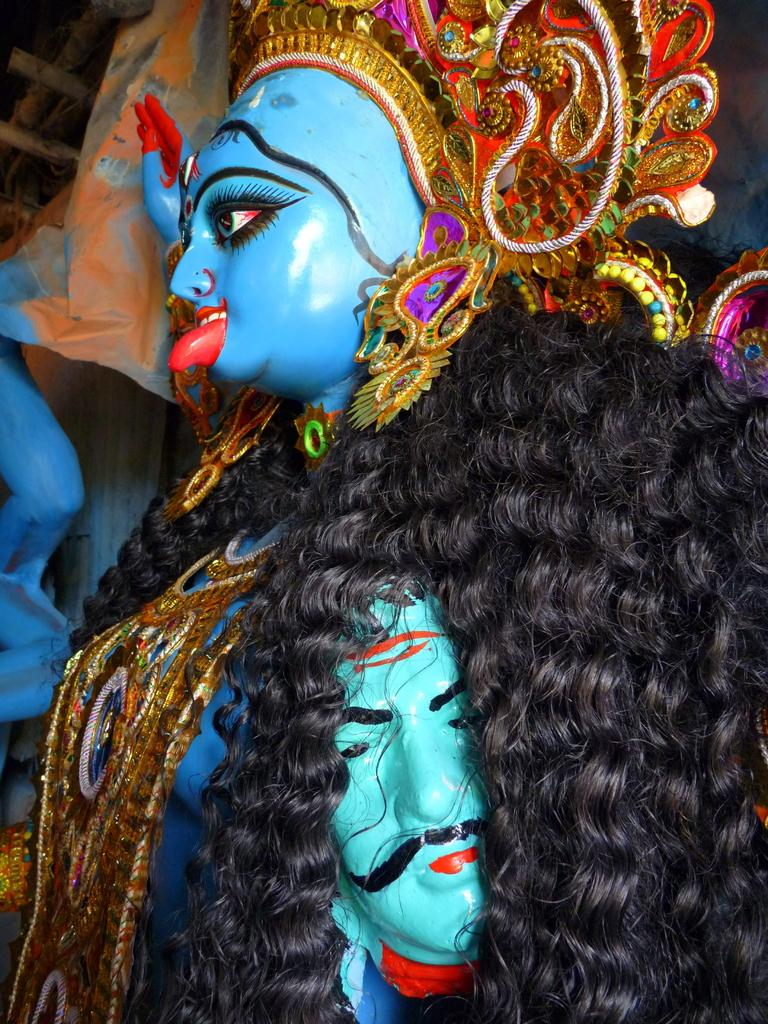What type of artwork is present in the image? There are sculptures of a woman and a man in the image. How are the sculptures positioned in relation to each other? The sculptures are in front of each other. What can be said about the appearance of the sculptures? The sculptures are colorful. What type of boundary can be seen between the two sculptures in the image? There is no boundary visible between the two sculptures in the image. How tall are the giants in the image? There are no giants present in the image; it features sculptures of a woman and a man. 